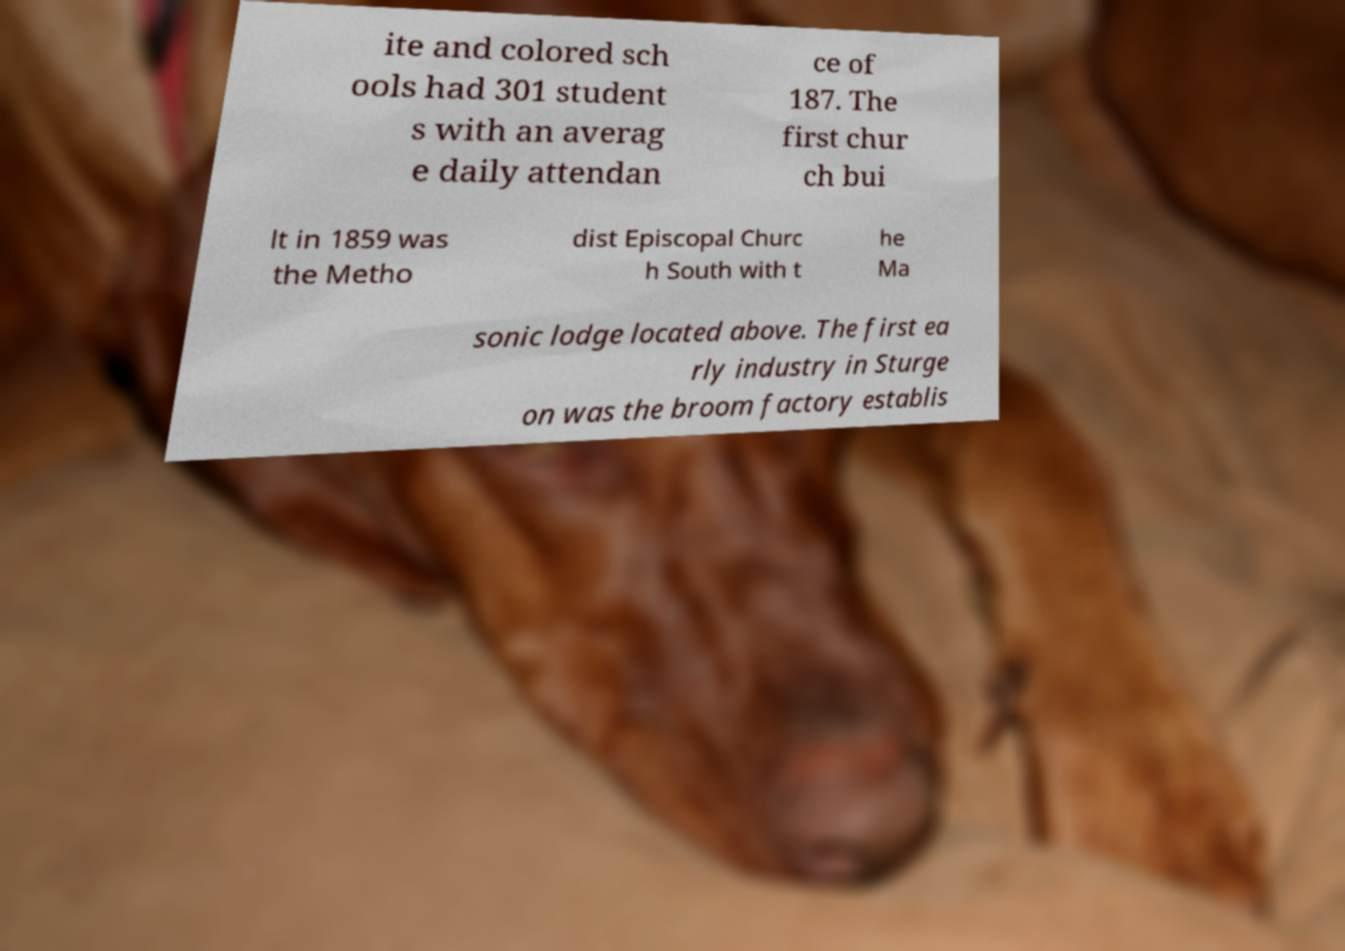Can you read and provide the text displayed in the image?This photo seems to have some interesting text. Can you extract and type it out for me? ite and colored sch ools had 301 student s with an averag e daily attendan ce of 187. The first chur ch bui lt in 1859 was the Metho dist Episcopal Churc h South with t he Ma sonic lodge located above. The first ea rly industry in Sturge on was the broom factory establis 